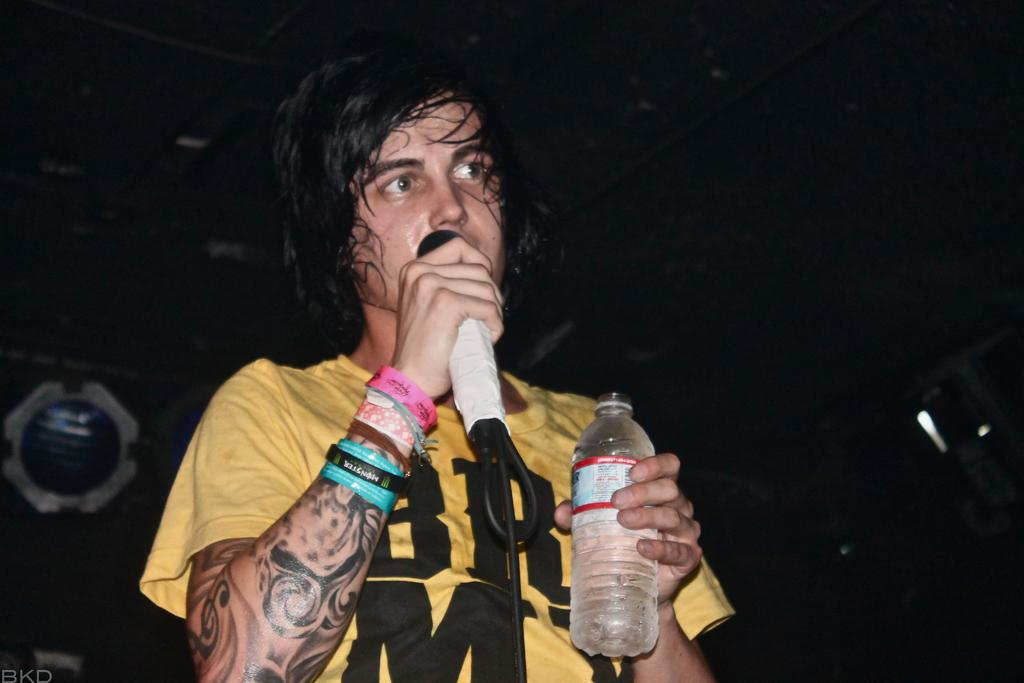What is the person in the image doing? The person is holding a mic and a bottle, which suggests they might be performing or giving a speech. What color combination is featured on the person's t-shirt? The person is wearing a yellow and black t-shirt. What accessories does the person have on their hands? The person has wrist bands on their hands. What type of cake is being pushed around in the image? There is no cake present in the image, and no pushing is taking place. 